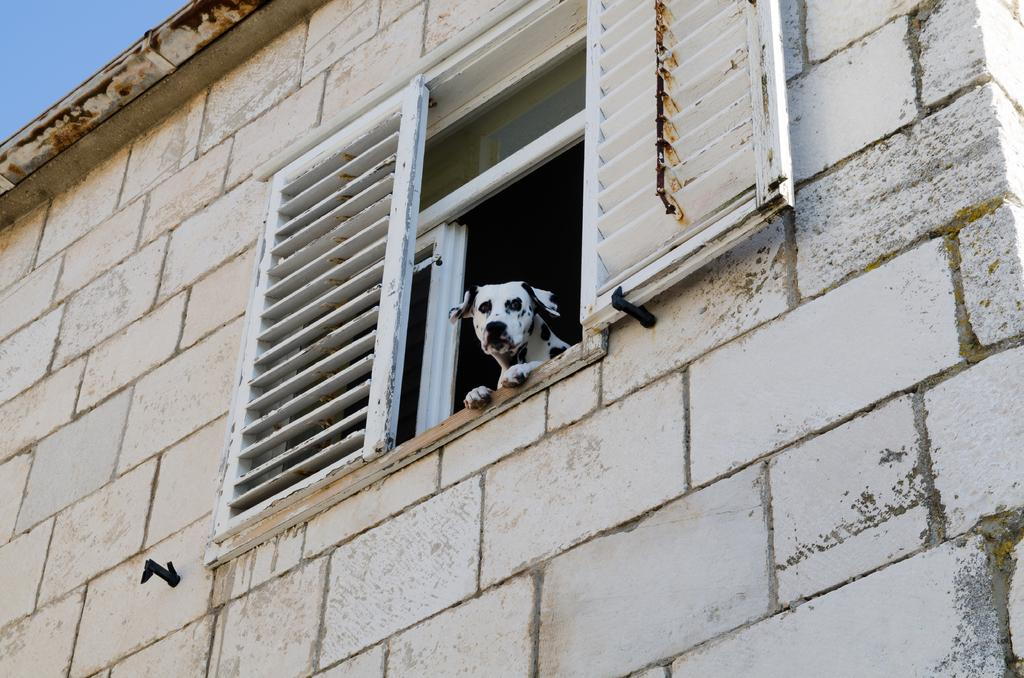What is present on the wall in the image? There is a window in the wall in the image. What can be seen through the window? A dog is visible in the image, and it is looking outside through the window. What is the dog doing in the image? The dog is looking outside through the window. What type of beef is the dog eating in the image? There is no beef present in the image; the dog is looking outside through the window. How does the dog contribute to world peace in the image? The image does not depict the dog's contribution to world peace, as it is focused on the dog looking outside through the window. 